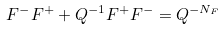<formula> <loc_0><loc_0><loc_500><loc_500>F ^ { - } F ^ { + } + Q ^ { - 1 } F ^ { + } F ^ { - } = Q ^ { - N _ { F } }</formula> 